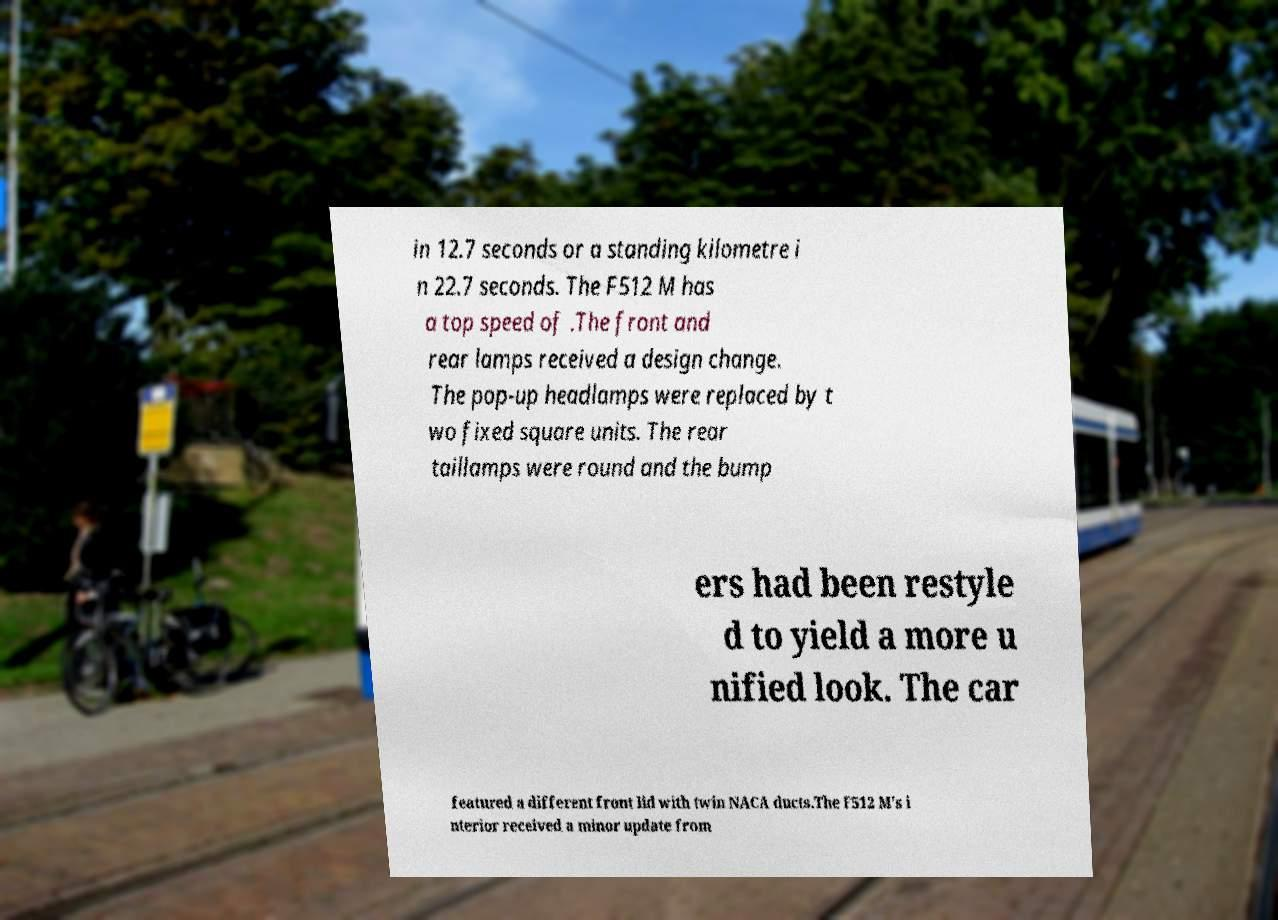Could you assist in decoding the text presented in this image and type it out clearly? in 12.7 seconds or a standing kilometre i n 22.7 seconds. The F512 M has a top speed of .The front and rear lamps received a design change. The pop-up headlamps were replaced by t wo fixed square units. The rear taillamps were round and the bump ers had been restyle d to yield a more u nified look. The car featured a different front lid with twin NACA ducts.The F512 M's i nterior received a minor update from 